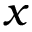Convert formula to latex. <formula><loc_0><loc_0><loc_500><loc_500>x</formula> 